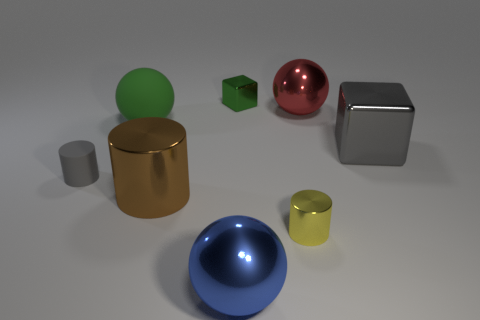Is the tiny matte cylinder the same color as the large metallic cube?
Offer a terse response. Yes. Is the material of the block that is behind the green sphere the same as the large green object?
Keep it short and to the point. No. What number of big metal things are both in front of the large red object and to the right of the large blue metallic thing?
Ensure brevity in your answer.  1. What number of red objects are made of the same material as the big gray thing?
Ensure brevity in your answer.  1. What is the color of the small object that is the same material as the yellow cylinder?
Offer a very short reply. Green. Is the number of blue metallic spheres less than the number of large yellow metal objects?
Offer a very short reply. No. There is a large object that is behind the large sphere left of the ball in front of the rubber sphere; what is it made of?
Ensure brevity in your answer.  Metal. What material is the big green object?
Provide a succinct answer. Rubber. There is a metal cube that is left of the big shiny block; is it the same color as the sphere that is on the left side of the big blue object?
Ensure brevity in your answer.  Yes. Are there more brown metal cubes than gray cubes?
Offer a terse response. No. 